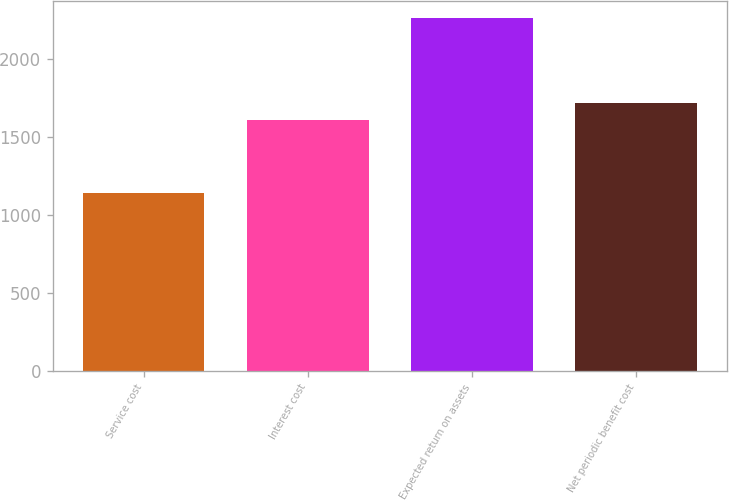Convert chart to OTSL. <chart><loc_0><loc_0><loc_500><loc_500><bar_chart><fcel>Service cost<fcel>Interest cost<fcel>Expected return on assets<fcel>Net periodic benefit cost<nl><fcel>1137<fcel>1604<fcel>2257<fcel>1716<nl></chart> 